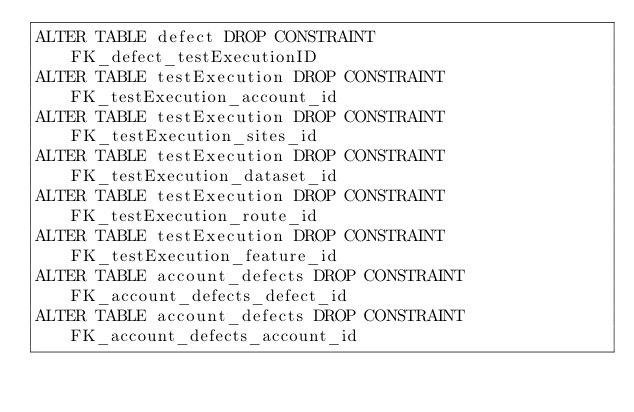Convert code to text. <code><loc_0><loc_0><loc_500><loc_500><_SQL_>ALTER TABLE defect DROP CONSTRAINT FK_defect_testExecutionID
ALTER TABLE testExecution DROP CONSTRAINT FK_testExecution_account_id
ALTER TABLE testExecution DROP CONSTRAINT FK_testExecution_sites_id
ALTER TABLE testExecution DROP CONSTRAINT FK_testExecution_dataset_id
ALTER TABLE testExecution DROP CONSTRAINT FK_testExecution_route_id
ALTER TABLE testExecution DROP CONSTRAINT FK_testExecution_feature_id
ALTER TABLE account_defects DROP CONSTRAINT FK_account_defects_defect_id
ALTER TABLE account_defects DROP CONSTRAINT FK_account_defects_account_id</code> 